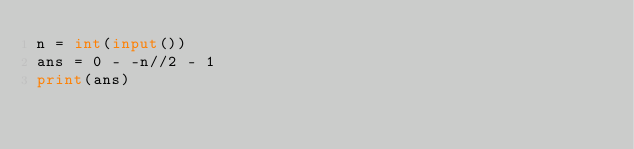Convert code to text. <code><loc_0><loc_0><loc_500><loc_500><_Python_>n = int(input())
ans = 0 - -n//2 - 1
print(ans)</code> 